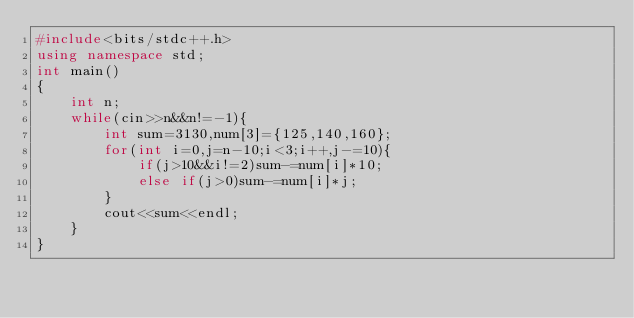<code> <loc_0><loc_0><loc_500><loc_500><_C++_>#include<bits/stdc++.h>
using namespace std;
int main()
{
    int n;
    while(cin>>n&&n!=-1){
        int sum=3130,num[3]={125,140,160};
        for(int i=0,j=n-10;i<3;i++,j-=10){
            if(j>10&&i!=2)sum-=num[i]*10;
            else if(j>0)sum-=num[i]*j;
        }
        cout<<sum<<endl;
    }
}</code> 